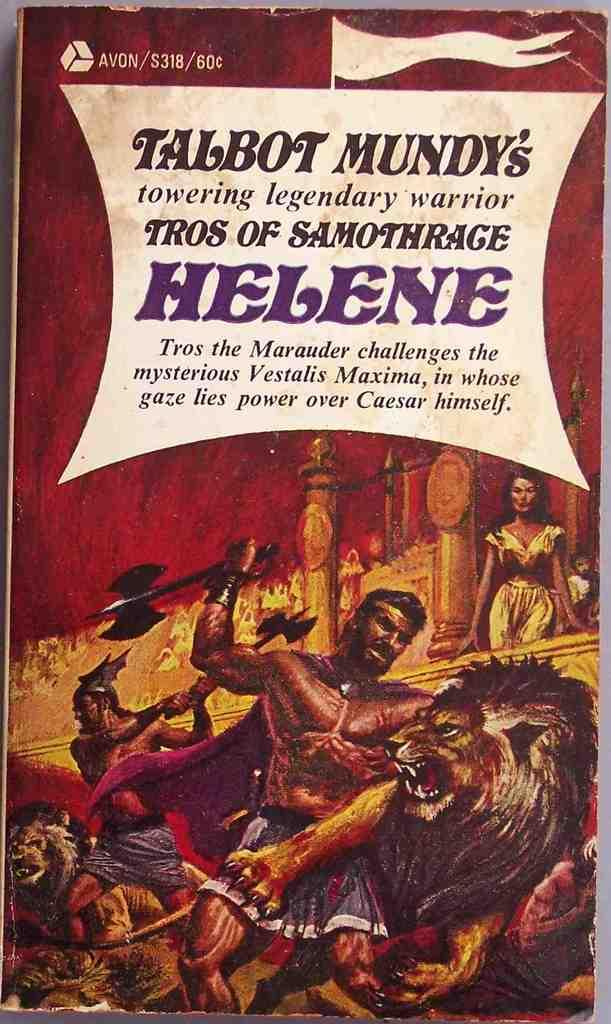What is the main subject of the image? The main subject of the image is the cover page of a book. What types of images are present on the cover page? The cover page contains images of people and lions. Is there any text on the cover page? Yes, there is text on the cover page. What type of collar can be seen on the lions in the image? There are no collars present on the lions in the image, as they are depicted in their natural state. How many birds are visible on the cover page? There are no birds visible on the cover page; it features images of people and lions. 